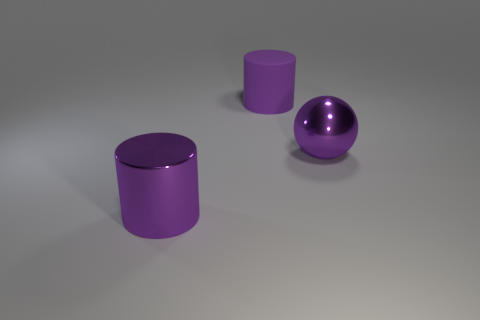Add 2 large brown objects. How many objects exist? 5 Subtract all spheres. How many objects are left? 2 Add 2 balls. How many balls exist? 3 Subtract 0 brown cylinders. How many objects are left? 3 Subtract 2 cylinders. How many cylinders are left? 0 Subtract all gray spheres. Subtract all cyan blocks. How many spheres are left? 1 Subtract all yellow spheres. How many yellow cylinders are left? 0 Subtract all purple metal balls. Subtract all cylinders. How many objects are left? 0 Add 2 purple shiny objects. How many purple shiny objects are left? 4 